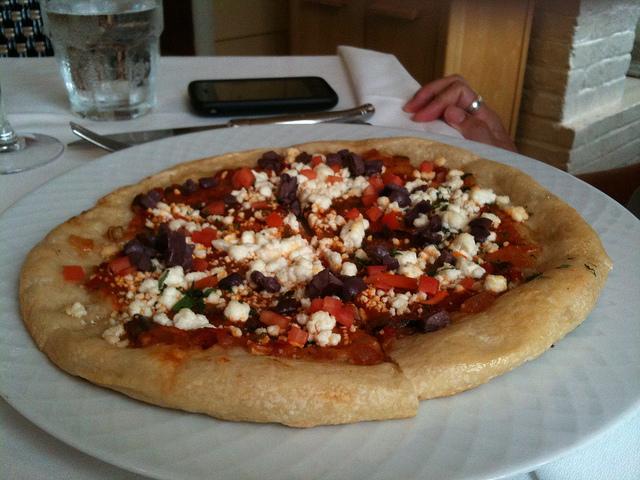What food is served?
Answer briefly. Pizza. Is the cell phone ringing?
Be succinct. No. How many pizzas are pictured?
Quick response, please. 1. Is someone sitting at the table?
Short answer required. Yes. 